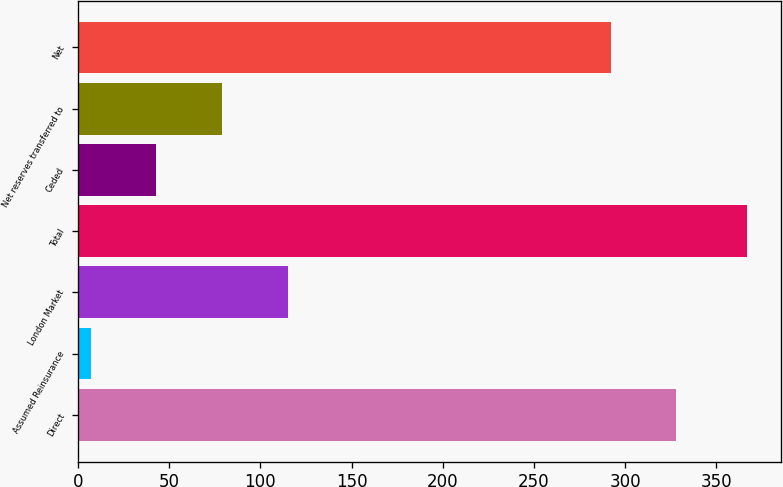Convert chart to OTSL. <chart><loc_0><loc_0><loc_500><loc_500><bar_chart><fcel>Direct<fcel>Assumed Reinsurance<fcel>London Market<fcel>Total<fcel>Ceded<fcel>Net reserves transferred to<fcel>Net<nl><fcel>328<fcel>7<fcel>115<fcel>367<fcel>43<fcel>79<fcel>292<nl></chart> 